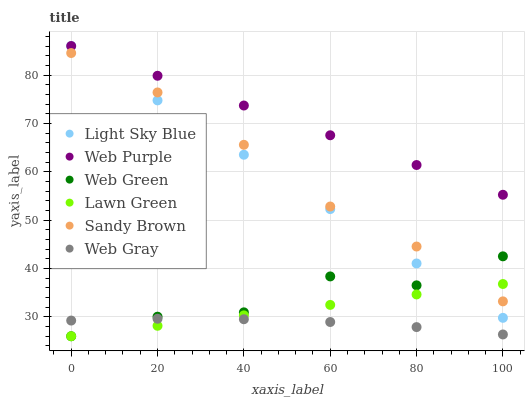Does Web Gray have the minimum area under the curve?
Answer yes or no. Yes. Does Web Purple have the maximum area under the curve?
Answer yes or no. Yes. Does Web Green have the minimum area under the curve?
Answer yes or no. No. Does Web Green have the maximum area under the curve?
Answer yes or no. No. Is Web Purple the smoothest?
Answer yes or no. Yes. Is Web Green the roughest?
Answer yes or no. Yes. Is Web Gray the smoothest?
Answer yes or no. No. Is Web Gray the roughest?
Answer yes or no. No. Does Lawn Green have the lowest value?
Answer yes or no. Yes. Does Web Gray have the lowest value?
Answer yes or no. No. Does Light Sky Blue have the highest value?
Answer yes or no. Yes. Does Web Green have the highest value?
Answer yes or no. No. Is Web Gray less than Sandy Brown?
Answer yes or no. Yes. Is Web Purple greater than Lawn Green?
Answer yes or no. Yes. Does Light Sky Blue intersect Web Green?
Answer yes or no. Yes. Is Light Sky Blue less than Web Green?
Answer yes or no. No. Is Light Sky Blue greater than Web Green?
Answer yes or no. No. Does Web Gray intersect Sandy Brown?
Answer yes or no. No. 